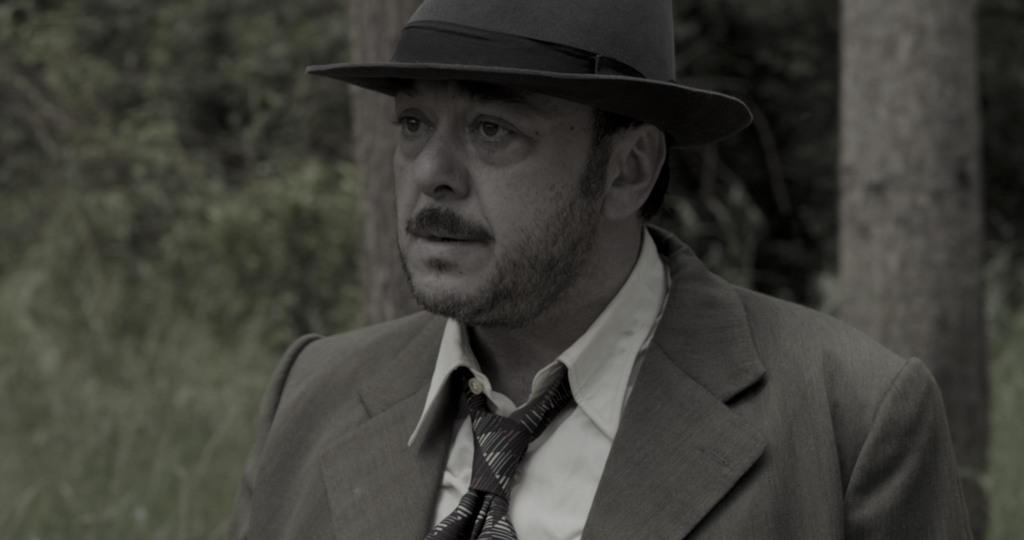What can be observed about the background of the image? The background of the image is blurred. What type of vegetation is present in the image? There are green leaves and tree trunks in the image. Can you describe the man in the image? The man in the image is wearing a shirt, a tie, a blazer, and a hat. What holiday is being celebrated in the image? There is no indication of a holiday being celebrated in the image. 